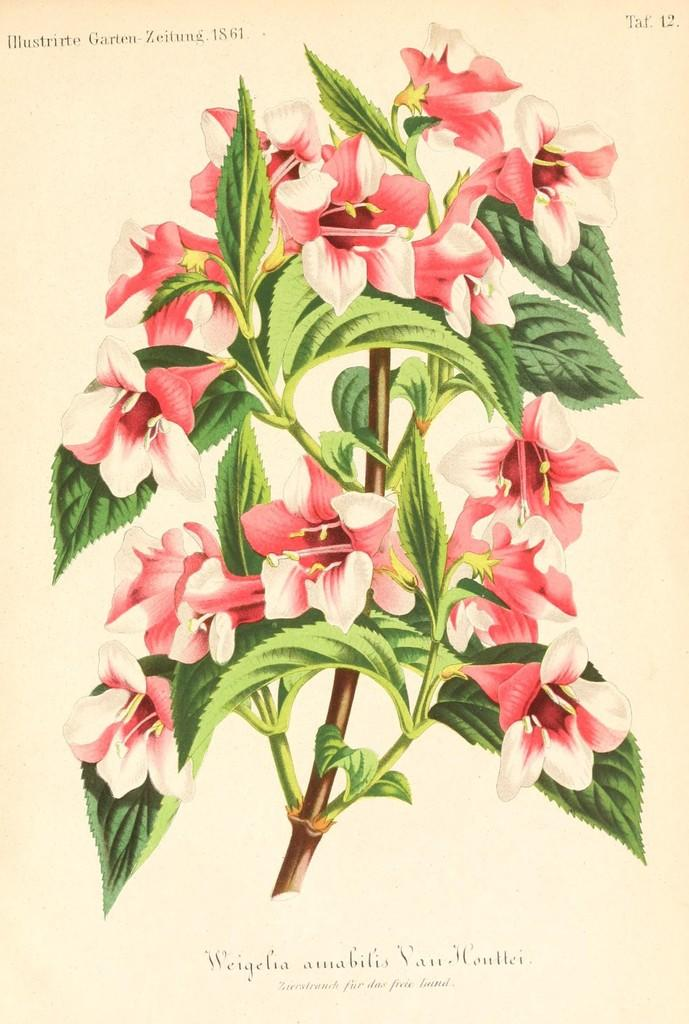What is the main subject of the image in the center? There is an image of flowers in the center of the picture. What else can be seen in the image besides the flowers? There are green leaves of a plant in the image. Are there any words or letters on the image? Yes, there is text on the image. Are there any numbers present in the image? Yes, there are numbers on the image. What event is taking place on this particular day in the image? There is no event or specific day mentioned or depicted in the image. 